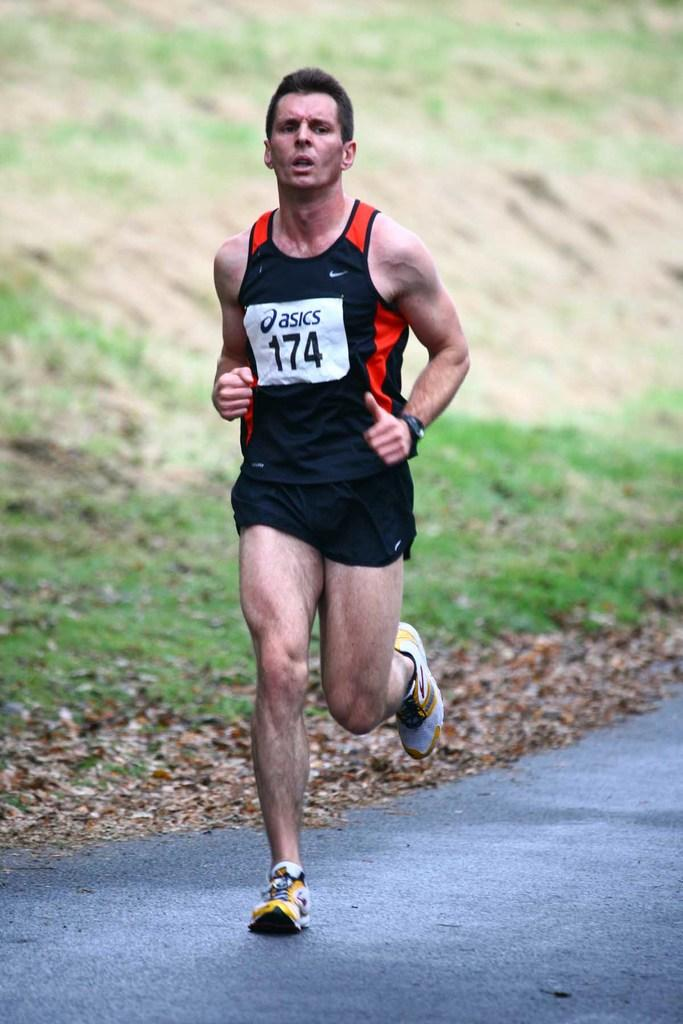Who is the main subject in the image? There is a boy in the image. What is the boy doing in the image? The boy is running on the road. Can you describe any additional details about the boy's appearance? The boy has a number badge on his shirt. What can be seen in the background of the image? There is grass in the background of the image. What is present on the ground in the image? There are dry leaves on the ground. What type of steam is coming out of the boy's ears in the image? There is no steam coming out of the boy's ears in the image; he is simply running on the road. 